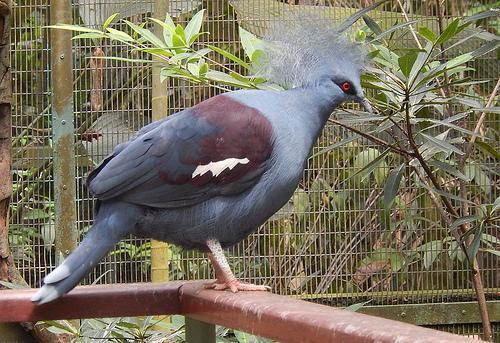How many birds are there?
Give a very brief answer. 1. 